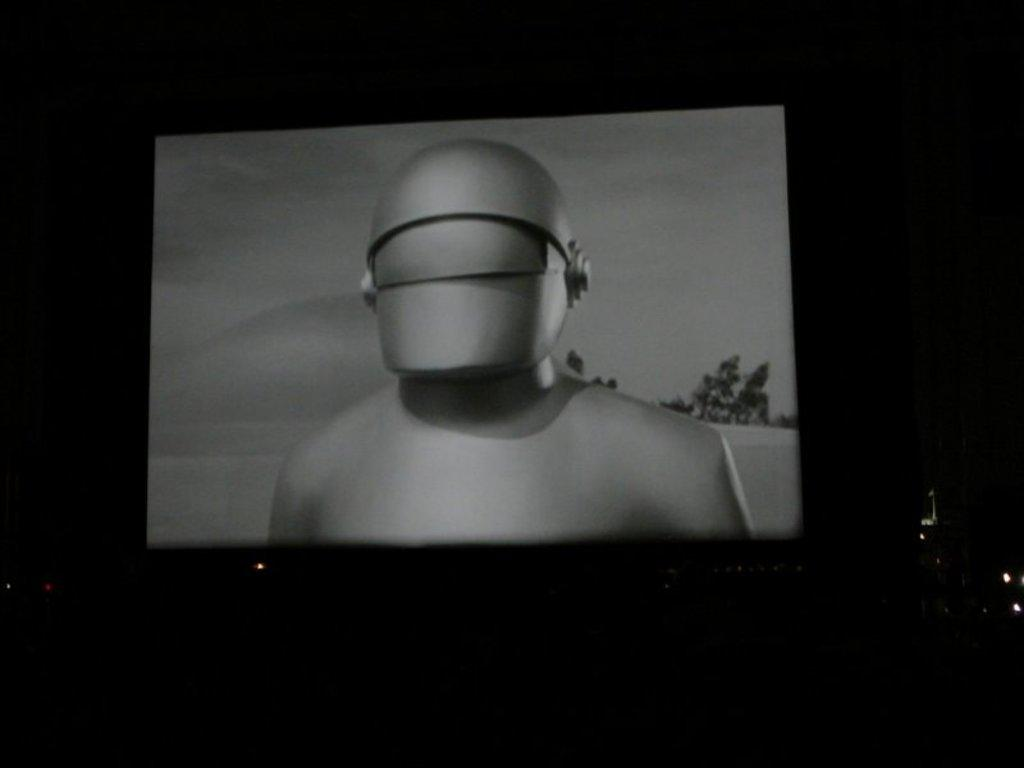What type of movie is being shown in the image? There is an old movie playing in the image. Where is the movie being shown? The movie is being shown in a theater. How many chickens are present in the image? There are no chickens present in the image. What type of furniture can be seen in the image? There is no furniture visible in the image; it is focused on the movie being shown in a theater. 